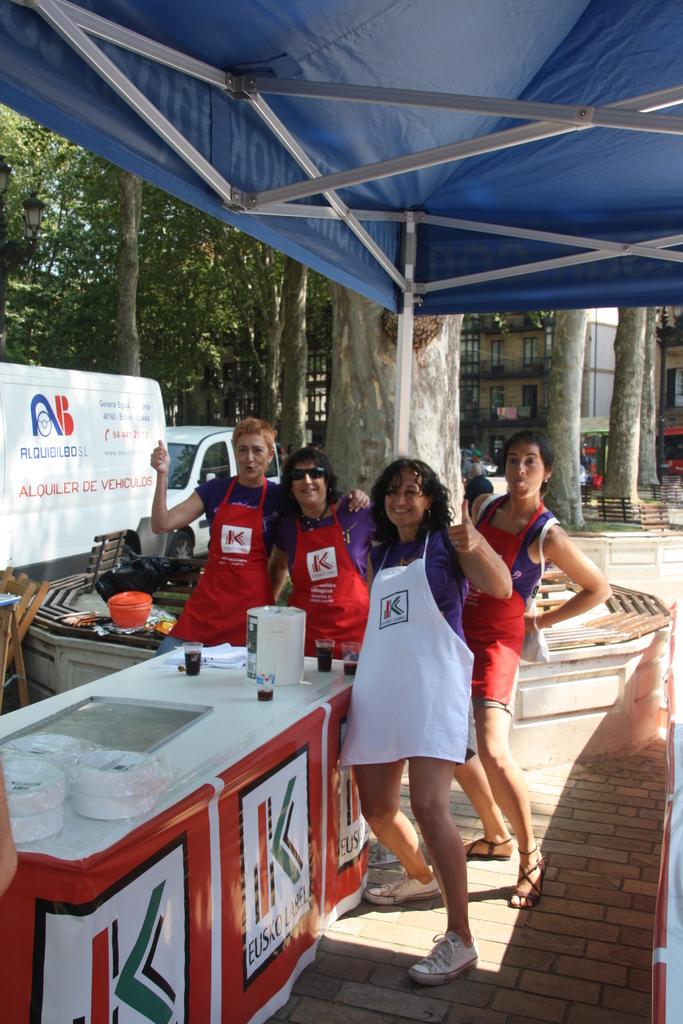Euskoloel cooking company?
Ensure brevity in your answer.  Yes. 